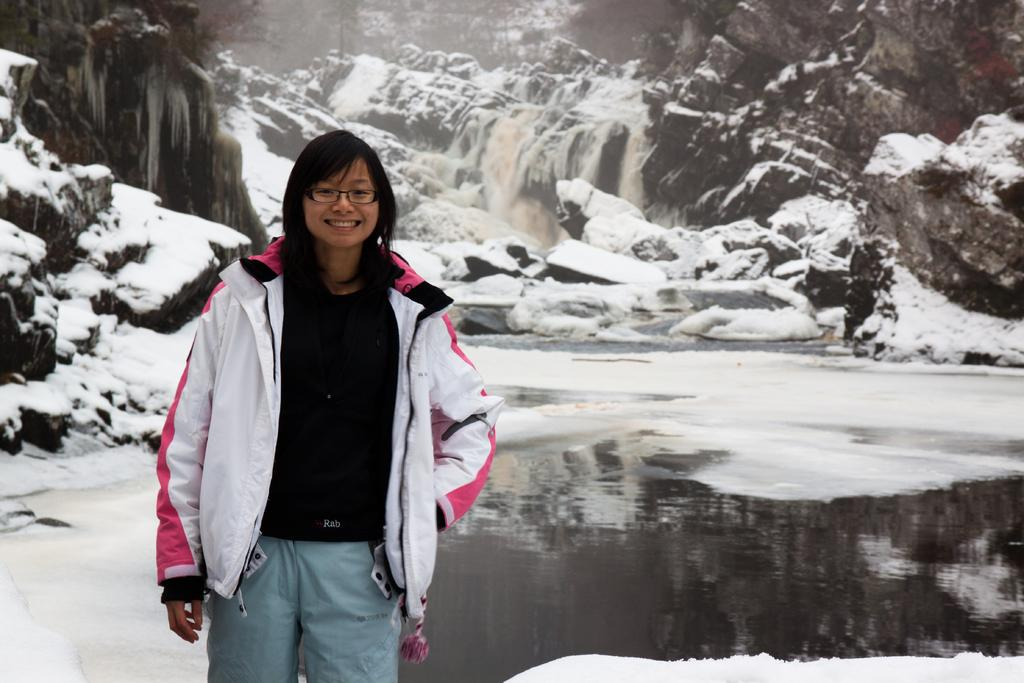Who is present in the image? There is a lady in the image. What is the lady doing in the image? The lady is standing with a smile on her face. What can be seen behind the lady? There is water visible on the surface behind the lady. What is visible in the background of the image? There is snow on the mountains and a waterfall in the background. What type of oil can be seen dripping from the lady's hair in the image? There is no oil visible in the image, and the lady's hair does not appear to be dripping with any substance. 